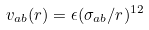<formula> <loc_0><loc_0><loc_500><loc_500>v _ { a b } ( r ) = \epsilon ( \sigma _ { a b } / r ) ^ { 1 2 }</formula> 